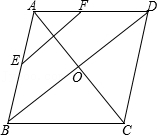Clarify your interpretation of the image. The diagram consists of a diamond-shaped figure labeled as ABCD. Points E and F are marked on the midpoints of the edges AB and AD, respectively. 